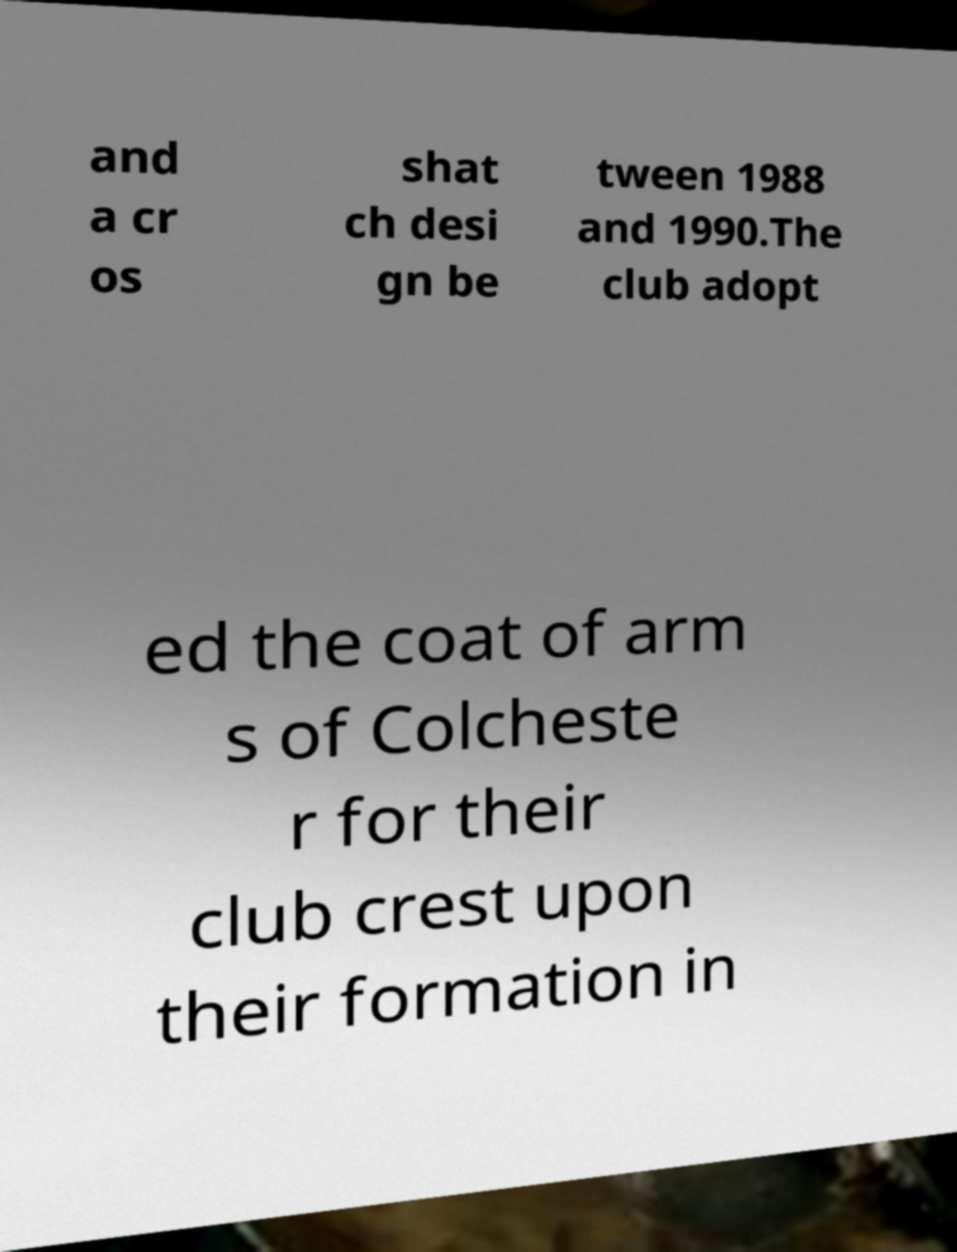Can you accurately transcribe the text from the provided image for me? and a cr os shat ch desi gn be tween 1988 and 1990.The club adopt ed the coat of arm s of Colcheste r for their club crest upon their formation in 